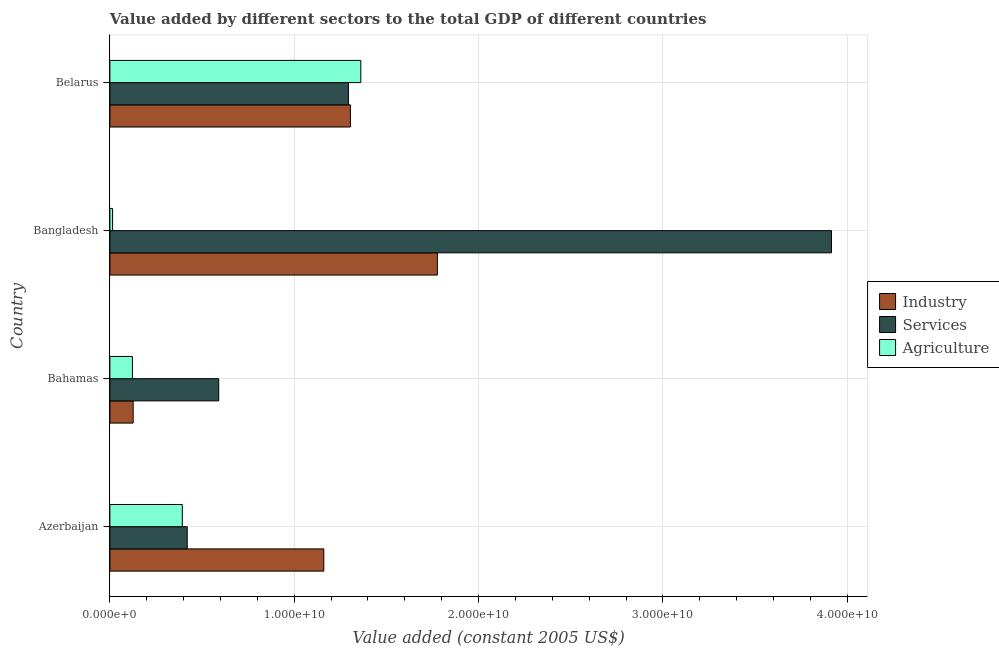How many different coloured bars are there?
Your response must be concise. 3. How many bars are there on the 2nd tick from the top?
Ensure brevity in your answer.  3. How many bars are there on the 1st tick from the bottom?
Give a very brief answer. 3. What is the label of the 1st group of bars from the top?
Offer a terse response. Belarus. In how many cases, is the number of bars for a given country not equal to the number of legend labels?
Provide a short and direct response. 0. What is the value added by agricultural sector in Belarus?
Ensure brevity in your answer.  1.36e+1. Across all countries, what is the maximum value added by agricultural sector?
Make the answer very short. 1.36e+1. Across all countries, what is the minimum value added by agricultural sector?
Your answer should be very brief. 1.45e+08. In which country was the value added by agricultural sector maximum?
Ensure brevity in your answer.  Belarus. In which country was the value added by industrial sector minimum?
Provide a short and direct response. Bahamas. What is the total value added by industrial sector in the graph?
Ensure brevity in your answer.  4.37e+1. What is the difference between the value added by industrial sector in Azerbaijan and that in Bangladesh?
Provide a succinct answer. -6.16e+09. What is the difference between the value added by services in Azerbaijan and the value added by agricultural sector in Bahamas?
Offer a terse response. 2.97e+09. What is the average value added by agricultural sector per country?
Your response must be concise. 4.73e+09. What is the difference between the value added by services and value added by industrial sector in Azerbaijan?
Your response must be concise. -7.41e+09. What is the ratio of the value added by services in Bahamas to that in Bangladesh?
Make the answer very short. 0.15. Is the value added by services in Bahamas less than that in Belarus?
Your answer should be compact. Yes. What is the difference between the highest and the second highest value added by industrial sector?
Ensure brevity in your answer.  4.72e+09. What is the difference between the highest and the lowest value added by industrial sector?
Your answer should be compact. 1.65e+1. Is the sum of the value added by agricultural sector in Bahamas and Belarus greater than the maximum value added by services across all countries?
Keep it short and to the point. No. What does the 2nd bar from the top in Belarus represents?
Your answer should be very brief. Services. What does the 3rd bar from the bottom in Bangladesh represents?
Provide a short and direct response. Agriculture. Are all the bars in the graph horizontal?
Provide a short and direct response. Yes. What is the difference between two consecutive major ticks on the X-axis?
Keep it short and to the point. 1.00e+1. Are the values on the major ticks of X-axis written in scientific E-notation?
Provide a succinct answer. Yes. Does the graph contain any zero values?
Your answer should be very brief. No. Does the graph contain grids?
Your answer should be very brief. Yes. Where does the legend appear in the graph?
Your answer should be compact. Center right. How many legend labels are there?
Your answer should be very brief. 3. How are the legend labels stacked?
Provide a succinct answer. Vertical. What is the title of the graph?
Your answer should be very brief. Value added by different sectors to the total GDP of different countries. What is the label or title of the X-axis?
Ensure brevity in your answer.  Value added (constant 2005 US$). What is the label or title of the Y-axis?
Ensure brevity in your answer.  Country. What is the Value added (constant 2005 US$) of Industry in Azerbaijan?
Make the answer very short. 1.16e+1. What is the Value added (constant 2005 US$) in Services in Azerbaijan?
Keep it short and to the point. 4.20e+09. What is the Value added (constant 2005 US$) in Agriculture in Azerbaijan?
Give a very brief answer. 3.93e+09. What is the Value added (constant 2005 US$) of Industry in Bahamas?
Ensure brevity in your answer.  1.26e+09. What is the Value added (constant 2005 US$) in Services in Bahamas?
Offer a terse response. 5.90e+09. What is the Value added (constant 2005 US$) of Agriculture in Bahamas?
Offer a very short reply. 1.22e+09. What is the Value added (constant 2005 US$) in Industry in Bangladesh?
Your answer should be very brief. 1.78e+1. What is the Value added (constant 2005 US$) in Services in Bangladesh?
Give a very brief answer. 3.91e+1. What is the Value added (constant 2005 US$) in Agriculture in Bangladesh?
Keep it short and to the point. 1.45e+08. What is the Value added (constant 2005 US$) of Industry in Belarus?
Your answer should be compact. 1.30e+1. What is the Value added (constant 2005 US$) of Services in Belarus?
Offer a terse response. 1.29e+1. What is the Value added (constant 2005 US$) in Agriculture in Belarus?
Your response must be concise. 1.36e+1. Across all countries, what is the maximum Value added (constant 2005 US$) of Industry?
Keep it short and to the point. 1.78e+1. Across all countries, what is the maximum Value added (constant 2005 US$) in Services?
Ensure brevity in your answer.  3.91e+1. Across all countries, what is the maximum Value added (constant 2005 US$) in Agriculture?
Your response must be concise. 1.36e+1. Across all countries, what is the minimum Value added (constant 2005 US$) in Industry?
Provide a succinct answer. 1.26e+09. Across all countries, what is the minimum Value added (constant 2005 US$) in Services?
Offer a terse response. 4.20e+09. Across all countries, what is the minimum Value added (constant 2005 US$) of Agriculture?
Your response must be concise. 1.45e+08. What is the total Value added (constant 2005 US$) in Industry in the graph?
Provide a short and direct response. 4.37e+1. What is the total Value added (constant 2005 US$) in Services in the graph?
Offer a very short reply. 6.22e+1. What is the total Value added (constant 2005 US$) of Agriculture in the graph?
Your answer should be compact. 1.89e+1. What is the difference between the Value added (constant 2005 US$) in Industry in Azerbaijan and that in Bahamas?
Your answer should be compact. 1.03e+1. What is the difference between the Value added (constant 2005 US$) in Services in Azerbaijan and that in Bahamas?
Provide a succinct answer. -1.71e+09. What is the difference between the Value added (constant 2005 US$) in Agriculture in Azerbaijan and that in Bahamas?
Your answer should be compact. 2.71e+09. What is the difference between the Value added (constant 2005 US$) of Industry in Azerbaijan and that in Bangladesh?
Give a very brief answer. -6.16e+09. What is the difference between the Value added (constant 2005 US$) in Services in Azerbaijan and that in Bangladesh?
Provide a succinct answer. -3.49e+1. What is the difference between the Value added (constant 2005 US$) of Agriculture in Azerbaijan and that in Bangladesh?
Provide a short and direct response. 3.78e+09. What is the difference between the Value added (constant 2005 US$) in Industry in Azerbaijan and that in Belarus?
Your answer should be compact. -1.44e+09. What is the difference between the Value added (constant 2005 US$) in Services in Azerbaijan and that in Belarus?
Provide a succinct answer. -8.75e+09. What is the difference between the Value added (constant 2005 US$) of Agriculture in Azerbaijan and that in Belarus?
Provide a succinct answer. -9.68e+09. What is the difference between the Value added (constant 2005 US$) of Industry in Bahamas and that in Bangladesh?
Your answer should be very brief. -1.65e+1. What is the difference between the Value added (constant 2005 US$) of Services in Bahamas and that in Bangladesh?
Your answer should be very brief. -3.32e+1. What is the difference between the Value added (constant 2005 US$) in Agriculture in Bahamas and that in Bangladesh?
Offer a very short reply. 1.08e+09. What is the difference between the Value added (constant 2005 US$) in Industry in Bahamas and that in Belarus?
Your answer should be very brief. -1.18e+1. What is the difference between the Value added (constant 2005 US$) in Services in Bahamas and that in Belarus?
Make the answer very short. -7.04e+09. What is the difference between the Value added (constant 2005 US$) of Agriculture in Bahamas and that in Belarus?
Offer a terse response. -1.24e+1. What is the difference between the Value added (constant 2005 US$) of Industry in Bangladesh and that in Belarus?
Provide a short and direct response. 4.72e+09. What is the difference between the Value added (constant 2005 US$) of Services in Bangladesh and that in Belarus?
Make the answer very short. 2.62e+1. What is the difference between the Value added (constant 2005 US$) of Agriculture in Bangladesh and that in Belarus?
Ensure brevity in your answer.  -1.35e+1. What is the difference between the Value added (constant 2005 US$) in Industry in Azerbaijan and the Value added (constant 2005 US$) in Services in Bahamas?
Keep it short and to the point. 5.70e+09. What is the difference between the Value added (constant 2005 US$) in Industry in Azerbaijan and the Value added (constant 2005 US$) in Agriculture in Bahamas?
Offer a very short reply. 1.04e+1. What is the difference between the Value added (constant 2005 US$) of Services in Azerbaijan and the Value added (constant 2005 US$) of Agriculture in Bahamas?
Give a very brief answer. 2.97e+09. What is the difference between the Value added (constant 2005 US$) in Industry in Azerbaijan and the Value added (constant 2005 US$) in Services in Bangladesh?
Your answer should be compact. -2.75e+1. What is the difference between the Value added (constant 2005 US$) in Industry in Azerbaijan and the Value added (constant 2005 US$) in Agriculture in Bangladesh?
Your response must be concise. 1.15e+1. What is the difference between the Value added (constant 2005 US$) of Services in Azerbaijan and the Value added (constant 2005 US$) of Agriculture in Bangladesh?
Give a very brief answer. 4.05e+09. What is the difference between the Value added (constant 2005 US$) in Industry in Azerbaijan and the Value added (constant 2005 US$) in Services in Belarus?
Make the answer very short. -1.34e+09. What is the difference between the Value added (constant 2005 US$) in Industry in Azerbaijan and the Value added (constant 2005 US$) in Agriculture in Belarus?
Offer a very short reply. -2.01e+09. What is the difference between the Value added (constant 2005 US$) of Services in Azerbaijan and the Value added (constant 2005 US$) of Agriculture in Belarus?
Your response must be concise. -9.42e+09. What is the difference between the Value added (constant 2005 US$) in Industry in Bahamas and the Value added (constant 2005 US$) in Services in Bangladesh?
Your response must be concise. -3.79e+1. What is the difference between the Value added (constant 2005 US$) of Industry in Bahamas and the Value added (constant 2005 US$) of Agriculture in Bangladesh?
Your response must be concise. 1.12e+09. What is the difference between the Value added (constant 2005 US$) in Services in Bahamas and the Value added (constant 2005 US$) in Agriculture in Bangladesh?
Offer a terse response. 5.76e+09. What is the difference between the Value added (constant 2005 US$) of Industry in Bahamas and the Value added (constant 2005 US$) of Services in Belarus?
Provide a short and direct response. -1.17e+1. What is the difference between the Value added (constant 2005 US$) of Industry in Bahamas and the Value added (constant 2005 US$) of Agriculture in Belarus?
Ensure brevity in your answer.  -1.24e+1. What is the difference between the Value added (constant 2005 US$) of Services in Bahamas and the Value added (constant 2005 US$) of Agriculture in Belarus?
Provide a short and direct response. -7.71e+09. What is the difference between the Value added (constant 2005 US$) in Industry in Bangladesh and the Value added (constant 2005 US$) in Services in Belarus?
Your answer should be very brief. 4.82e+09. What is the difference between the Value added (constant 2005 US$) of Industry in Bangladesh and the Value added (constant 2005 US$) of Agriculture in Belarus?
Give a very brief answer. 4.15e+09. What is the difference between the Value added (constant 2005 US$) in Services in Bangladesh and the Value added (constant 2005 US$) in Agriculture in Belarus?
Give a very brief answer. 2.55e+1. What is the average Value added (constant 2005 US$) of Industry per country?
Your response must be concise. 1.09e+1. What is the average Value added (constant 2005 US$) of Services per country?
Ensure brevity in your answer.  1.55e+1. What is the average Value added (constant 2005 US$) of Agriculture per country?
Provide a succinct answer. 4.73e+09. What is the difference between the Value added (constant 2005 US$) in Industry and Value added (constant 2005 US$) in Services in Azerbaijan?
Provide a succinct answer. 7.41e+09. What is the difference between the Value added (constant 2005 US$) of Industry and Value added (constant 2005 US$) of Agriculture in Azerbaijan?
Make the answer very short. 7.68e+09. What is the difference between the Value added (constant 2005 US$) of Services and Value added (constant 2005 US$) of Agriculture in Azerbaijan?
Offer a very short reply. 2.68e+08. What is the difference between the Value added (constant 2005 US$) of Industry and Value added (constant 2005 US$) of Services in Bahamas?
Offer a very short reply. -4.64e+09. What is the difference between the Value added (constant 2005 US$) of Industry and Value added (constant 2005 US$) of Agriculture in Bahamas?
Make the answer very short. 3.98e+07. What is the difference between the Value added (constant 2005 US$) in Services and Value added (constant 2005 US$) in Agriculture in Bahamas?
Offer a terse response. 4.68e+09. What is the difference between the Value added (constant 2005 US$) of Industry and Value added (constant 2005 US$) of Services in Bangladesh?
Keep it short and to the point. -2.14e+1. What is the difference between the Value added (constant 2005 US$) of Industry and Value added (constant 2005 US$) of Agriculture in Bangladesh?
Ensure brevity in your answer.  1.76e+1. What is the difference between the Value added (constant 2005 US$) in Services and Value added (constant 2005 US$) in Agriculture in Bangladesh?
Offer a terse response. 3.90e+1. What is the difference between the Value added (constant 2005 US$) in Industry and Value added (constant 2005 US$) in Services in Belarus?
Give a very brief answer. 1.07e+08. What is the difference between the Value added (constant 2005 US$) of Industry and Value added (constant 2005 US$) of Agriculture in Belarus?
Your answer should be very brief. -5.65e+08. What is the difference between the Value added (constant 2005 US$) of Services and Value added (constant 2005 US$) of Agriculture in Belarus?
Your response must be concise. -6.71e+08. What is the ratio of the Value added (constant 2005 US$) of Industry in Azerbaijan to that in Bahamas?
Give a very brief answer. 9.19. What is the ratio of the Value added (constant 2005 US$) in Services in Azerbaijan to that in Bahamas?
Provide a short and direct response. 0.71. What is the ratio of the Value added (constant 2005 US$) of Agriculture in Azerbaijan to that in Bahamas?
Provide a succinct answer. 3.21. What is the ratio of the Value added (constant 2005 US$) of Industry in Azerbaijan to that in Bangladesh?
Give a very brief answer. 0.65. What is the ratio of the Value added (constant 2005 US$) of Services in Azerbaijan to that in Bangladesh?
Your answer should be compact. 0.11. What is the ratio of the Value added (constant 2005 US$) of Agriculture in Azerbaijan to that in Bangladesh?
Ensure brevity in your answer.  27.12. What is the ratio of the Value added (constant 2005 US$) in Industry in Azerbaijan to that in Belarus?
Ensure brevity in your answer.  0.89. What is the ratio of the Value added (constant 2005 US$) in Services in Azerbaijan to that in Belarus?
Make the answer very short. 0.32. What is the ratio of the Value added (constant 2005 US$) in Agriculture in Azerbaijan to that in Belarus?
Your answer should be compact. 0.29. What is the ratio of the Value added (constant 2005 US$) of Industry in Bahamas to that in Bangladesh?
Give a very brief answer. 0.07. What is the ratio of the Value added (constant 2005 US$) in Services in Bahamas to that in Bangladesh?
Your answer should be very brief. 0.15. What is the ratio of the Value added (constant 2005 US$) in Agriculture in Bahamas to that in Bangladesh?
Offer a very short reply. 8.44. What is the ratio of the Value added (constant 2005 US$) in Industry in Bahamas to that in Belarus?
Provide a succinct answer. 0.1. What is the ratio of the Value added (constant 2005 US$) of Services in Bahamas to that in Belarus?
Your answer should be very brief. 0.46. What is the ratio of the Value added (constant 2005 US$) in Agriculture in Bahamas to that in Belarus?
Provide a short and direct response. 0.09. What is the ratio of the Value added (constant 2005 US$) of Industry in Bangladesh to that in Belarus?
Ensure brevity in your answer.  1.36. What is the ratio of the Value added (constant 2005 US$) in Services in Bangladesh to that in Belarus?
Offer a terse response. 3.02. What is the ratio of the Value added (constant 2005 US$) in Agriculture in Bangladesh to that in Belarus?
Offer a very short reply. 0.01. What is the difference between the highest and the second highest Value added (constant 2005 US$) in Industry?
Keep it short and to the point. 4.72e+09. What is the difference between the highest and the second highest Value added (constant 2005 US$) in Services?
Provide a succinct answer. 2.62e+1. What is the difference between the highest and the second highest Value added (constant 2005 US$) in Agriculture?
Make the answer very short. 9.68e+09. What is the difference between the highest and the lowest Value added (constant 2005 US$) in Industry?
Keep it short and to the point. 1.65e+1. What is the difference between the highest and the lowest Value added (constant 2005 US$) in Services?
Offer a very short reply. 3.49e+1. What is the difference between the highest and the lowest Value added (constant 2005 US$) in Agriculture?
Your response must be concise. 1.35e+1. 